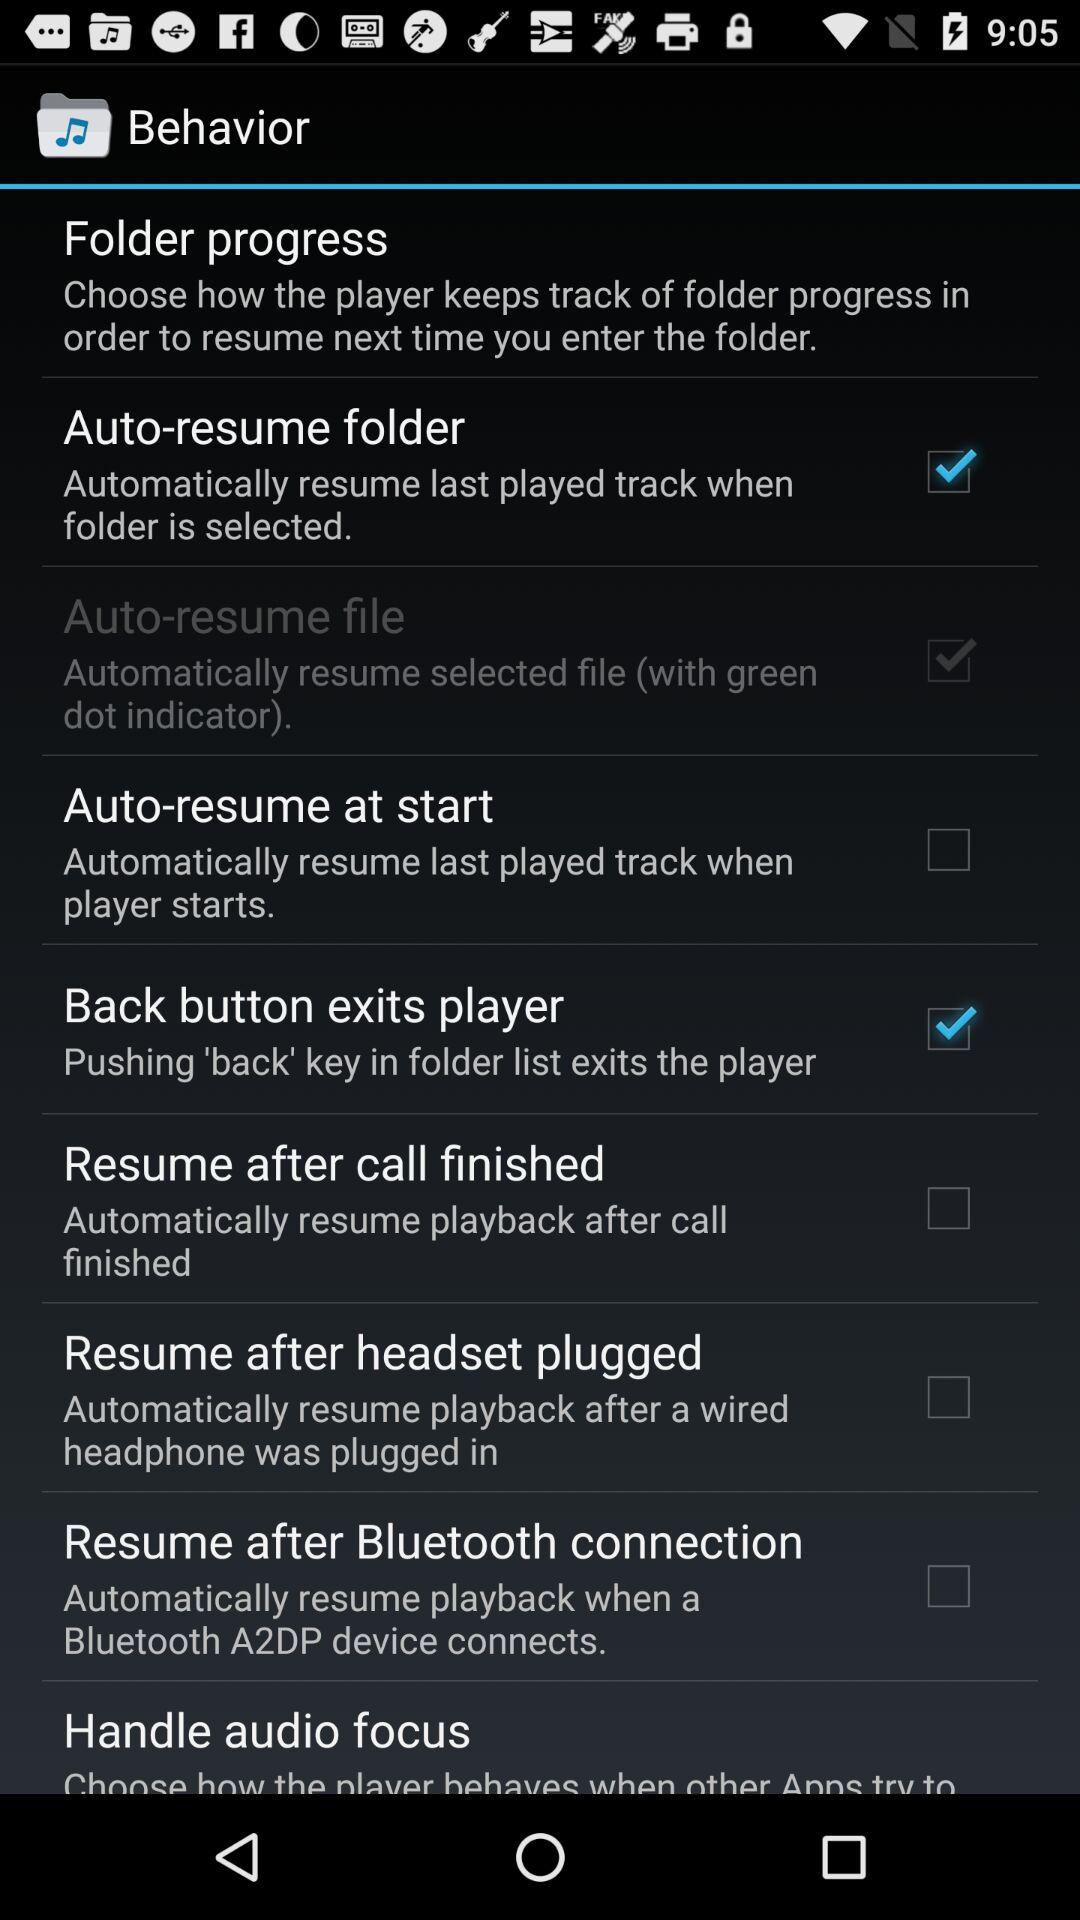What is the status of the "Auto-resume folder"? The status is "on". 